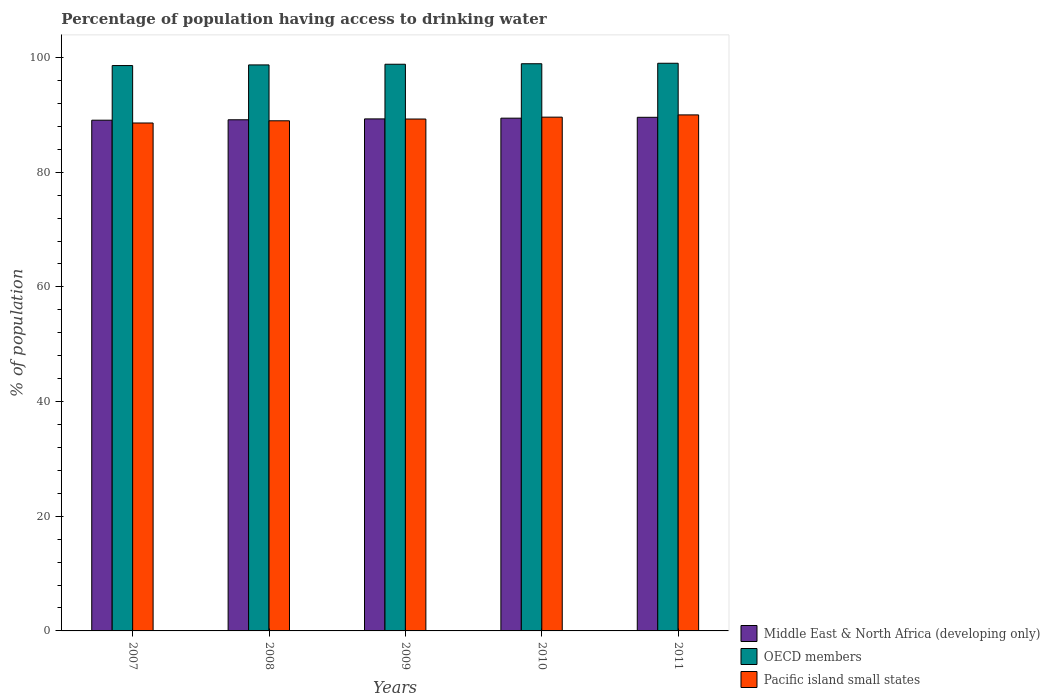How many groups of bars are there?
Your answer should be very brief. 5. Are the number of bars on each tick of the X-axis equal?
Your answer should be compact. Yes. How many bars are there on the 4th tick from the right?
Provide a succinct answer. 3. What is the label of the 2nd group of bars from the left?
Give a very brief answer. 2008. What is the percentage of population having access to drinking water in Middle East & North Africa (developing only) in 2007?
Provide a short and direct response. 89.07. Across all years, what is the maximum percentage of population having access to drinking water in Pacific island small states?
Provide a short and direct response. 89.99. Across all years, what is the minimum percentage of population having access to drinking water in OECD members?
Your answer should be compact. 98.6. In which year was the percentage of population having access to drinking water in OECD members maximum?
Your answer should be very brief. 2011. What is the total percentage of population having access to drinking water in OECD members in the graph?
Keep it short and to the point. 494.06. What is the difference between the percentage of population having access to drinking water in OECD members in 2009 and that in 2010?
Your answer should be compact. -0.09. What is the difference between the percentage of population having access to drinking water in Pacific island small states in 2011 and the percentage of population having access to drinking water in OECD members in 2010?
Your answer should be compact. -8.92. What is the average percentage of population having access to drinking water in OECD members per year?
Your response must be concise. 98.81. In the year 2010, what is the difference between the percentage of population having access to drinking water in Middle East & North Africa (developing only) and percentage of population having access to drinking water in Pacific island small states?
Ensure brevity in your answer.  -0.18. What is the ratio of the percentage of population having access to drinking water in OECD members in 2007 to that in 2011?
Ensure brevity in your answer.  1. Is the percentage of population having access to drinking water in Pacific island small states in 2008 less than that in 2009?
Give a very brief answer. Yes. Is the difference between the percentage of population having access to drinking water in Middle East & North Africa (developing only) in 2008 and 2010 greater than the difference between the percentage of population having access to drinking water in Pacific island small states in 2008 and 2010?
Your response must be concise. Yes. What is the difference between the highest and the second highest percentage of population having access to drinking water in Middle East & North Africa (developing only)?
Your response must be concise. 0.15. What is the difference between the highest and the lowest percentage of population having access to drinking water in Pacific island small states?
Your response must be concise. 1.41. What does the 3rd bar from the left in 2011 represents?
Offer a terse response. Pacific island small states. What does the 3rd bar from the right in 2008 represents?
Your answer should be very brief. Middle East & North Africa (developing only). Does the graph contain grids?
Ensure brevity in your answer.  No. Where does the legend appear in the graph?
Your answer should be compact. Bottom right. How many legend labels are there?
Offer a terse response. 3. How are the legend labels stacked?
Provide a succinct answer. Vertical. What is the title of the graph?
Offer a very short reply. Percentage of population having access to drinking water. What is the label or title of the Y-axis?
Ensure brevity in your answer.  % of population. What is the % of population of Middle East & North Africa (developing only) in 2007?
Keep it short and to the point. 89.07. What is the % of population in OECD members in 2007?
Give a very brief answer. 98.6. What is the % of population in Pacific island small states in 2007?
Ensure brevity in your answer.  88.58. What is the % of population in Middle East & North Africa (developing only) in 2008?
Make the answer very short. 89.14. What is the % of population in OECD members in 2008?
Offer a terse response. 98.71. What is the % of population in Pacific island small states in 2008?
Provide a succinct answer. 88.97. What is the % of population of Middle East & North Africa (developing only) in 2009?
Offer a terse response. 89.3. What is the % of population in OECD members in 2009?
Give a very brief answer. 98.83. What is the % of population in Pacific island small states in 2009?
Give a very brief answer. 89.28. What is the % of population in Middle East & North Africa (developing only) in 2010?
Offer a terse response. 89.42. What is the % of population in OECD members in 2010?
Ensure brevity in your answer.  98.92. What is the % of population of Pacific island small states in 2010?
Provide a short and direct response. 89.6. What is the % of population in Middle East & North Africa (developing only) in 2011?
Your answer should be compact. 89.57. What is the % of population in OECD members in 2011?
Make the answer very short. 99. What is the % of population of Pacific island small states in 2011?
Your answer should be very brief. 89.99. Across all years, what is the maximum % of population in Middle East & North Africa (developing only)?
Offer a terse response. 89.57. Across all years, what is the maximum % of population in OECD members?
Give a very brief answer. 99. Across all years, what is the maximum % of population of Pacific island small states?
Give a very brief answer. 89.99. Across all years, what is the minimum % of population of Middle East & North Africa (developing only)?
Provide a short and direct response. 89.07. Across all years, what is the minimum % of population in OECD members?
Your answer should be compact. 98.6. Across all years, what is the minimum % of population in Pacific island small states?
Make the answer very short. 88.58. What is the total % of population in Middle East & North Africa (developing only) in the graph?
Your answer should be compact. 446.51. What is the total % of population in OECD members in the graph?
Offer a terse response. 494.06. What is the total % of population of Pacific island small states in the graph?
Your answer should be compact. 446.42. What is the difference between the % of population of Middle East & North Africa (developing only) in 2007 and that in 2008?
Your response must be concise. -0.07. What is the difference between the % of population of OECD members in 2007 and that in 2008?
Your answer should be very brief. -0.11. What is the difference between the % of population of Pacific island small states in 2007 and that in 2008?
Make the answer very short. -0.38. What is the difference between the % of population in Middle East & North Africa (developing only) in 2007 and that in 2009?
Provide a succinct answer. -0.23. What is the difference between the % of population in OECD members in 2007 and that in 2009?
Offer a very short reply. -0.23. What is the difference between the % of population in Pacific island small states in 2007 and that in 2009?
Provide a succinct answer. -0.69. What is the difference between the % of population in Middle East & North Africa (developing only) in 2007 and that in 2010?
Keep it short and to the point. -0.35. What is the difference between the % of population of OECD members in 2007 and that in 2010?
Make the answer very short. -0.32. What is the difference between the % of population of Pacific island small states in 2007 and that in 2010?
Your answer should be very brief. -1.02. What is the difference between the % of population of Middle East & North Africa (developing only) in 2007 and that in 2011?
Make the answer very short. -0.5. What is the difference between the % of population in OECD members in 2007 and that in 2011?
Offer a very short reply. -0.4. What is the difference between the % of population of Pacific island small states in 2007 and that in 2011?
Provide a succinct answer. -1.41. What is the difference between the % of population in Middle East & North Africa (developing only) in 2008 and that in 2009?
Ensure brevity in your answer.  -0.15. What is the difference between the % of population of OECD members in 2008 and that in 2009?
Make the answer very short. -0.12. What is the difference between the % of population in Pacific island small states in 2008 and that in 2009?
Your answer should be compact. -0.31. What is the difference between the % of population in Middle East & North Africa (developing only) in 2008 and that in 2010?
Your response must be concise. -0.28. What is the difference between the % of population in OECD members in 2008 and that in 2010?
Your answer should be compact. -0.21. What is the difference between the % of population in Pacific island small states in 2008 and that in 2010?
Give a very brief answer. -0.64. What is the difference between the % of population of Middle East & North Africa (developing only) in 2008 and that in 2011?
Provide a succinct answer. -0.43. What is the difference between the % of population of OECD members in 2008 and that in 2011?
Provide a succinct answer. -0.29. What is the difference between the % of population in Pacific island small states in 2008 and that in 2011?
Make the answer very short. -1.03. What is the difference between the % of population in Middle East & North Africa (developing only) in 2009 and that in 2010?
Offer a very short reply. -0.13. What is the difference between the % of population in OECD members in 2009 and that in 2010?
Make the answer very short. -0.09. What is the difference between the % of population of Pacific island small states in 2009 and that in 2010?
Your response must be concise. -0.33. What is the difference between the % of population of Middle East & North Africa (developing only) in 2009 and that in 2011?
Offer a very short reply. -0.28. What is the difference between the % of population in OECD members in 2009 and that in 2011?
Offer a terse response. -0.17. What is the difference between the % of population in Pacific island small states in 2009 and that in 2011?
Ensure brevity in your answer.  -0.72. What is the difference between the % of population of Middle East & North Africa (developing only) in 2010 and that in 2011?
Provide a short and direct response. -0.15. What is the difference between the % of population of OECD members in 2010 and that in 2011?
Make the answer very short. -0.08. What is the difference between the % of population of Pacific island small states in 2010 and that in 2011?
Give a very brief answer. -0.39. What is the difference between the % of population in Middle East & North Africa (developing only) in 2007 and the % of population in OECD members in 2008?
Offer a very short reply. -9.64. What is the difference between the % of population of Middle East & North Africa (developing only) in 2007 and the % of population of Pacific island small states in 2008?
Offer a terse response. 0.1. What is the difference between the % of population of OECD members in 2007 and the % of population of Pacific island small states in 2008?
Provide a succinct answer. 9.63. What is the difference between the % of population of Middle East & North Africa (developing only) in 2007 and the % of population of OECD members in 2009?
Give a very brief answer. -9.76. What is the difference between the % of population of Middle East & North Africa (developing only) in 2007 and the % of population of Pacific island small states in 2009?
Make the answer very short. -0.2. What is the difference between the % of population of OECD members in 2007 and the % of population of Pacific island small states in 2009?
Offer a terse response. 9.32. What is the difference between the % of population of Middle East & North Africa (developing only) in 2007 and the % of population of OECD members in 2010?
Ensure brevity in your answer.  -9.85. What is the difference between the % of population in Middle East & North Africa (developing only) in 2007 and the % of population in Pacific island small states in 2010?
Offer a terse response. -0.53. What is the difference between the % of population in OECD members in 2007 and the % of population in Pacific island small states in 2010?
Make the answer very short. 9. What is the difference between the % of population in Middle East & North Africa (developing only) in 2007 and the % of population in OECD members in 2011?
Make the answer very short. -9.93. What is the difference between the % of population in Middle East & North Africa (developing only) in 2007 and the % of population in Pacific island small states in 2011?
Your answer should be compact. -0.92. What is the difference between the % of population in OECD members in 2007 and the % of population in Pacific island small states in 2011?
Offer a terse response. 8.61. What is the difference between the % of population in Middle East & North Africa (developing only) in 2008 and the % of population in OECD members in 2009?
Offer a terse response. -9.69. What is the difference between the % of population in Middle East & North Africa (developing only) in 2008 and the % of population in Pacific island small states in 2009?
Ensure brevity in your answer.  -0.13. What is the difference between the % of population in OECD members in 2008 and the % of population in Pacific island small states in 2009?
Make the answer very short. 9.44. What is the difference between the % of population in Middle East & North Africa (developing only) in 2008 and the % of population in OECD members in 2010?
Make the answer very short. -9.77. What is the difference between the % of population in Middle East & North Africa (developing only) in 2008 and the % of population in Pacific island small states in 2010?
Provide a short and direct response. -0.46. What is the difference between the % of population of OECD members in 2008 and the % of population of Pacific island small states in 2010?
Your answer should be very brief. 9.11. What is the difference between the % of population of Middle East & North Africa (developing only) in 2008 and the % of population of OECD members in 2011?
Provide a succinct answer. -9.86. What is the difference between the % of population in Middle East & North Africa (developing only) in 2008 and the % of population in Pacific island small states in 2011?
Offer a very short reply. -0.85. What is the difference between the % of population of OECD members in 2008 and the % of population of Pacific island small states in 2011?
Make the answer very short. 8.72. What is the difference between the % of population in Middle East & North Africa (developing only) in 2009 and the % of population in OECD members in 2010?
Your answer should be compact. -9.62. What is the difference between the % of population in Middle East & North Africa (developing only) in 2009 and the % of population in Pacific island small states in 2010?
Offer a terse response. -0.31. What is the difference between the % of population in OECD members in 2009 and the % of population in Pacific island small states in 2010?
Offer a very short reply. 9.23. What is the difference between the % of population in Middle East & North Africa (developing only) in 2009 and the % of population in OECD members in 2011?
Your response must be concise. -9.7. What is the difference between the % of population of Middle East & North Africa (developing only) in 2009 and the % of population of Pacific island small states in 2011?
Your answer should be compact. -0.7. What is the difference between the % of population in OECD members in 2009 and the % of population in Pacific island small states in 2011?
Your response must be concise. 8.84. What is the difference between the % of population in Middle East & North Africa (developing only) in 2010 and the % of population in OECD members in 2011?
Your answer should be very brief. -9.58. What is the difference between the % of population in Middle East & North Africa (developing only) in 2010 and the % of population in Pacific island small states in 2011?
Provide a short and direct response. -0.57. What is the difference between the % of population in OECD members in 2010 and the % of population in Pacific island small states in 2011?
Offer a terse response. 8.92. What is the average % of population of Middle East & North Africa (developing only) per year?
Your answer should be very brief. 89.3. What is the average % of population in OECD members per year?
Offer a very short reply. 98.81. What is the average % of population in Pacific island small states per year?
Keep it short and to the point. 89.28. In the year 2007, what is the difference between the % of population in Middle East & North Africa (developing only) and % of population in OECD members?
Keep it short and to the point. -9.53. In the year 2007, what is the difference between the % of population in Middle East & North Africa (developing only) and % of population in Pacific island small states?
Ensure brevity in your answer.  0.49. In the year 2007, what is the difference between the % of population in OECD members and % of population in Pacific island small states?
Your answer should be very brief. 10.02. In the year 2008, what is the difference between the % of population in Middle East & North Africa (developing only) and % of population in OECD members?
Provide a short and direct response. -9.57. In the year 2008, what is the difference between the % of population in Middle East & North Africa (developing only) and % of population in Pacific island small states?
Make the answer very short. 0.18. In the year 2008, what is the difference between the % of population of OECD members and % of population of Pacific island small states?
Make the answer very short. 9.74. In the year 2009, what is the difference between the % of population of Middle East & North Africa (developing only) and % of population of OECD members?
Give a very brief answer. -9.53. In the year 2009, what is the difference between the % of population of Middle East & North Africa (developing only) and % of population of Pacific island small states?
Ensure brevity in your answer.  0.02. In the year 2009, what is the difference between the % of population of OECD members and % of population of Pacific island small states?
Give a very brief answer. 9.55. In the year 2010, what is the difference between the % of population of Middle East & North Africa (developing only) and % of population of OECD members?
Your response must be concise. -9.49. In the year 2010, what is the difference between the % of population of Middle East & North Africa (developing only) and % of population of Pacific island small states?
Provide a succinct answer. -0.18. In the year 2010, what is the difference between the % of population of OECD members and % of population of Pacific island small states?
Your answer should be compact. 9.31. In the year 2011, what is the difference between the % of population in Middle East & North Africa (developing only) and % of population in OECD members?
Your response must be concise. -9.43. In the year 2011, what is the difference between the % of population of Middle East & North Africa (developing only) and % of population of Pacific island small states?
Your answer should be very brief. -0.42. In the year 2011, what is the difference between the % of population in OECD members and % of population in Pacific island small states?
Keep it short and to the point. 9.01. What is the ratio of the % of population of OECD members in 2007 to that in 2008?
Offer a very short reply. 1. What is the ratio of the % of population of Pacific island small states in 2007 to that in 2008?
Make the answer very short. 1. What is the ratio of the % of population of OECD members in 2007 to that in 2010?
Give a very brief answer. 1. What is the ratio of the % of population in Pacific island small states in 2007 to that in 2011?
Give a very brief answer. 0.98. What is the ratio of the % of population of Middle East & North Africa (developing only) in 2008 to that in 2009?
Ensure brevity in your answer.  1. What is the ratio of the % of population of OECD members in 2008 to that in 2009?
Your answer should be very brief. 1. What is the ratio of the % of population in Pacific island small states in 2008 to that in 2010?
Give a very brief answer. 0.99. What is the ratio of the % of population of OECD members in 2008 to that in 2011?
Provide a succinct answer. 1. What is the ratio of the % of population in Pacific island small states in 2008 to that in 2011?
Provide a short and direct response. 0.99. What is the ratio of the % of population of Pacific island small states in 2009 to that in 2010?
Your answer should be very brief. 1. What is the ratio of the % of population in Middle East & North Africa (developing only) in 2009 to that in 2011?
Make the answer very short. 1. What is the ratio of the % of population of Pacific island small states in 2009 to that in 2011?
Your answer should be very brief. 0.99. What is the ratio of the % of population in Middle East & North Africa (developing only) in 2010 to that in 2011?
Provide a short and direct response. 1. What is the difference between the highest and the second highest % of population in Middle East & North Africa (developing only)?
Ensure brevity in your answer.  0.15. What is the difference between the highest and the second highest % of population of OECD members?
Provide a succinct answer. 0.08. What is the difference between the highest and the second highest % of population in Pacific island small states?
Offer a very short reply. 0.39. What is the difference between the highest and the lowest % of population of Middle East & North Africa (developing only)?
Your response must be concise. 0.5. What is the difference between the highest and the lowest % of population of OECD members?
Ensure brevity in your answer.  0.4. What is the difference between the highest and the lowest % of population of Pacific island small states?
Make the answer very short. 1.41. 